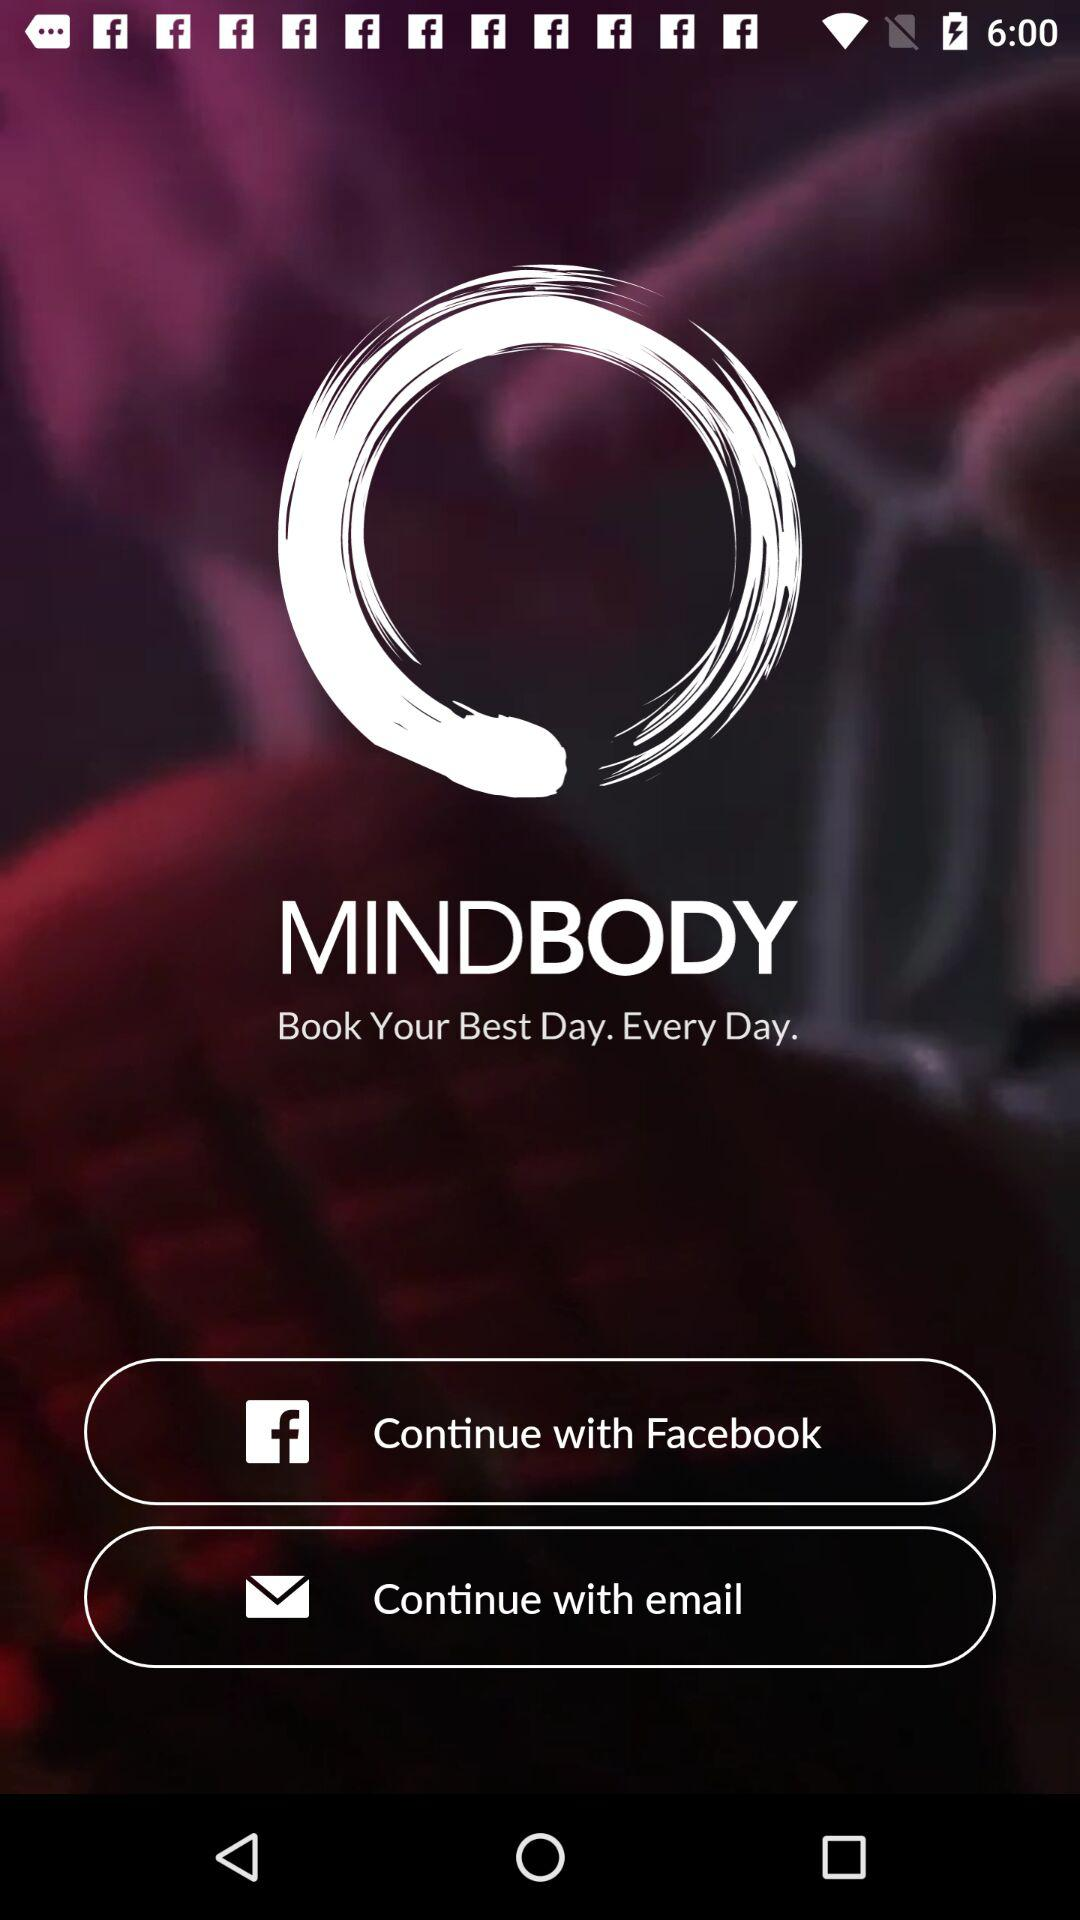What applications can be used to continue? The application that can be used to continue is "Facebook". 